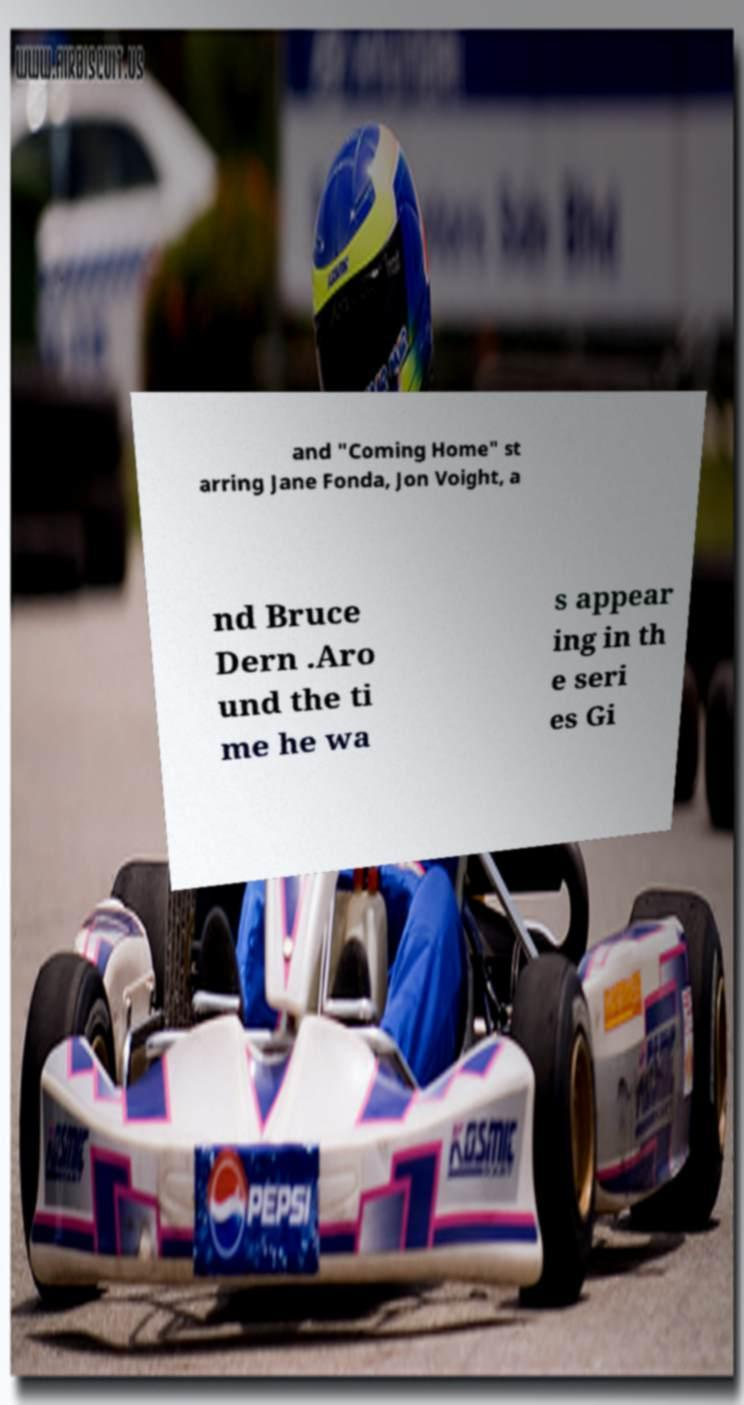There's text embedded in this image that I need extracted. Can you transcribe it verbatim? and "Coming Home" st arring Jane Fonda, Jon Voight, a nd Bruce Dern .Aro und the ti me he wa s appear ing in th e seri es Gi 